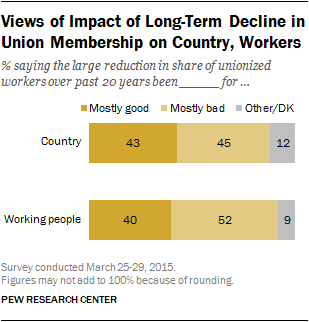Point out several critical features in this image. Ninety percent of working people are answering 'don't know' or 'other' in the survey. In the country, it is clear that one side holds a more positive view towards the reduction of union membership. 